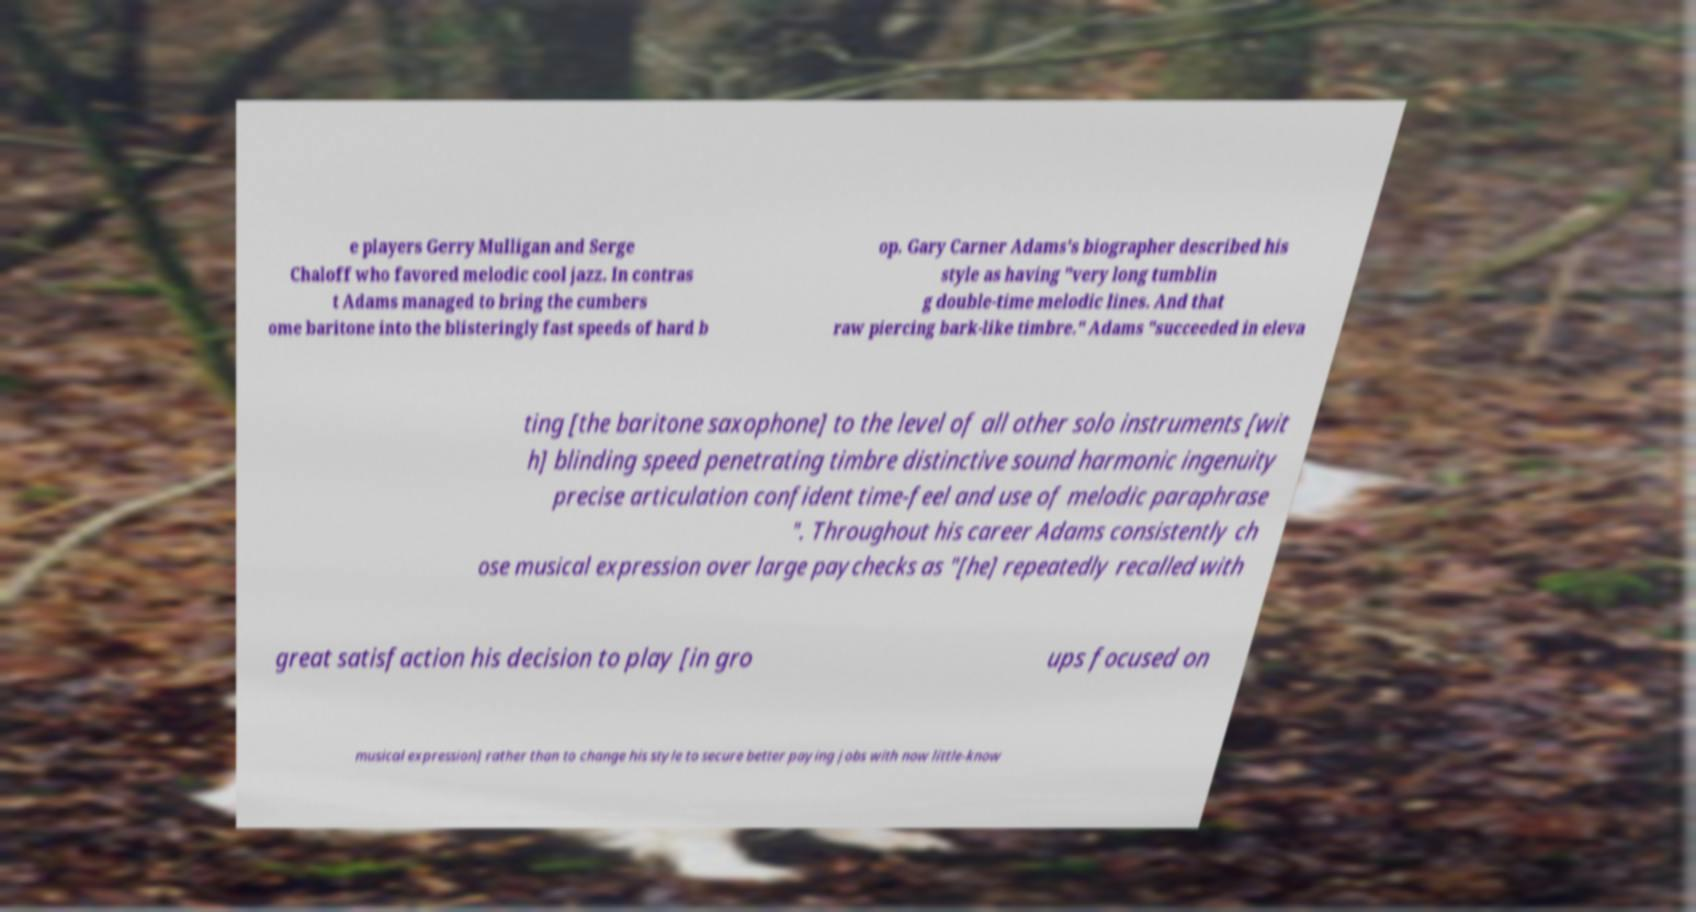Can you read and provide the text displayed in the image?This photo seems to have some interesting text. Can you extract and type it out for me? e players Gerry Mulligan and Serge Chaloff who favored melodic cool jazz. In contras t Adams managed to bring the cumbers ome baritone into the blisteringly fast speeds of hard b op. Gary Carner Adams's biographer described his style as having "very long tumblin g double-time melodic lines. And that raw piercing bark-like timbre." Adams "succeeded in eleva ting [the baritone saxophone] to the level of all other solo instruments [wit h] blinding speed penetrating timbre distinctive sound harmonic ingenuity precise articulation confident time-feel and use of melodic paraphrase ". Throughout his career Adams consistently ch ose musical expression over large paychecks as "[he] repeatedly recalled with great satisfaction his decision to play [in gro ups focused on musical expression] rather than to change his style to secure better paying jobs with now little-know 